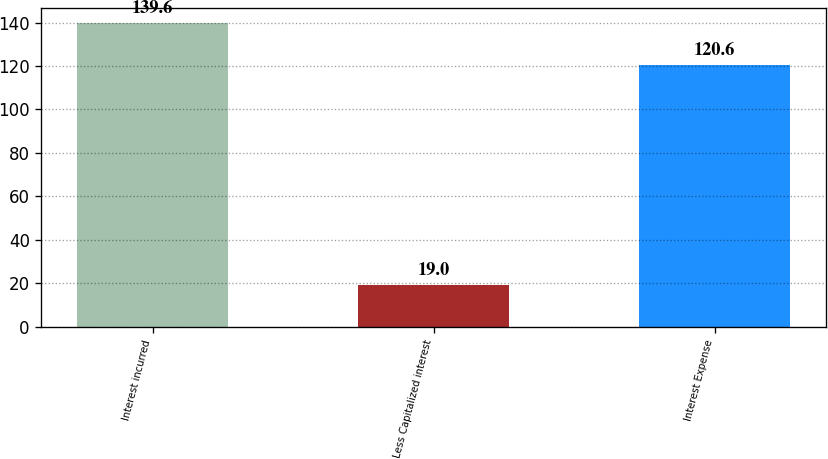<chart> <loc_0><loc_0><loc_500><loc_500><bar_chart><fcel>Interest incurred<fcel>Less Capitalized interest<fcel>Interest Expense<nl><fcel>139.6<fcel>19<fcel>120.6<nl></chart> 